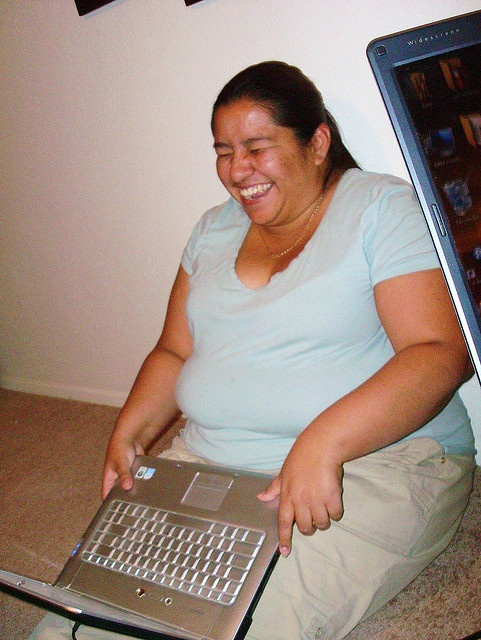Describe the objects in this image and their specific colors. I can see people in gray, darkgray, lightgray, lightblue, and salmon tones, laptop in gray and darkgray tones, and cell phone in gray, black, navy, and maroon tones in this image. 